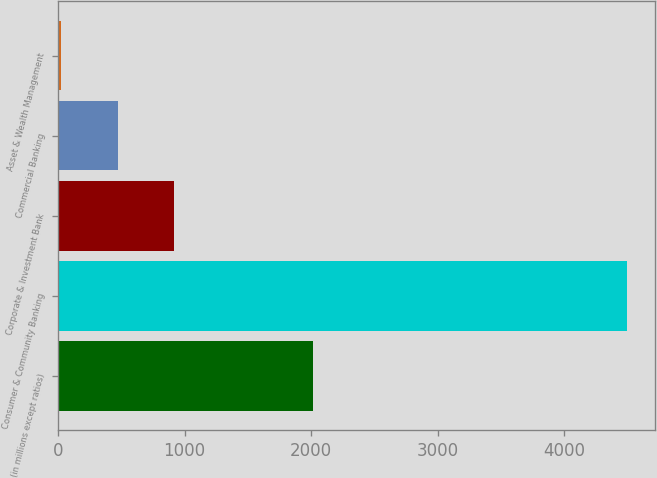Convert chart to OTSL. <chart><loc_0><loc_0><loc_500><loc_500><bar_chart><fcel>(in millions except ratios)<fcel>Consumer & Community Banking<fcel>Corporate & Investment Bank<fcel>Commercial Banking<fcel>Asset & Wealth Management<nl><fcel>2016<fcel>4494<fcel>919.6<fcel>472.8<fcel>26<nl></chart> 